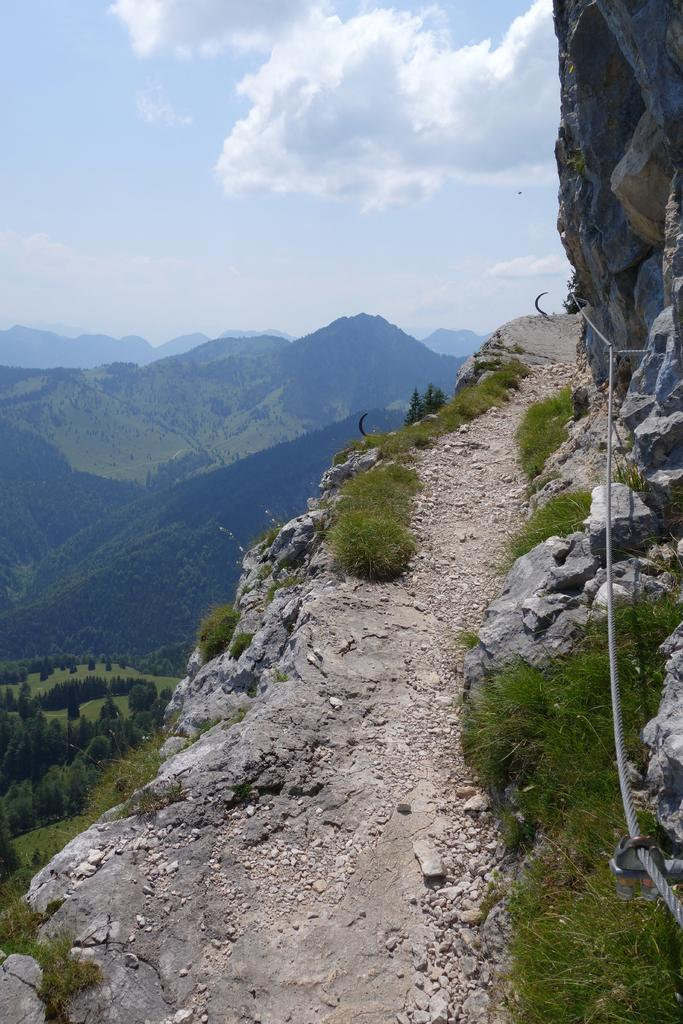What type of natural formation can be seen in the image? There are mountains in the image. What covers the mountains in the image? The mountains are covered with plants and trees. Can you describe the vegetation in the image? There are trees and plants visible in the image. What material can be seen in the image? There is stone visible in the image. What is visible in the sky in the image? There are clouds in the sky. What type of wall can be seen in the image? There is no wall present in the image; it features mountains covered with plants and trees. What is the starting point for the journey in the image? The image does not depict a journey or a starting point; it shows mountains, plants, trees, stone, and clouds. 